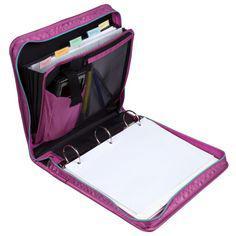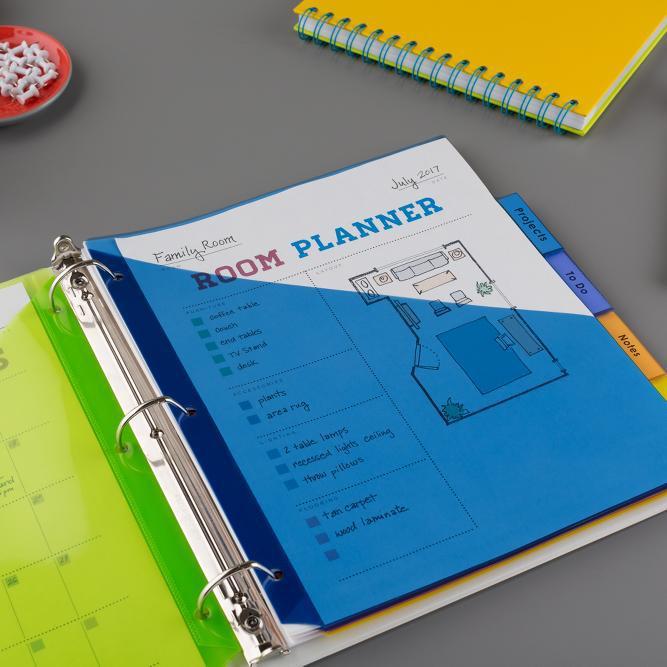The first image is the image on the left, the second image is the image on the right. Given the left and right images, does the statement "An image shows a binder with three metal rings lying open and completely flat on a surface, containing pages that aren't in the rings." hold true? Answer yes or no. Yes. The first image is the image on the left, the second image is the image on the right. Examine the images to the left and right. Is the description "The image to the right displays an open binder, and not just a notebook." accurate? Answer yes or no. Yes. 